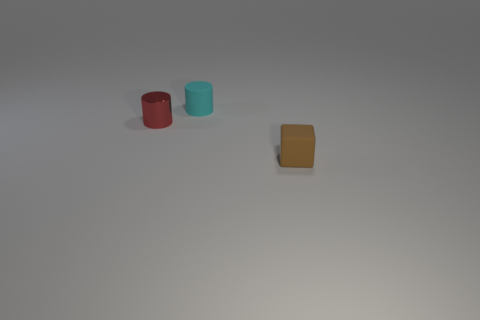Is there a large red matte ball?
Give a very brief answer. No. What shape is the tiny cyan object that is the same material as the tiny brown block?
Make the answer very short. Cylinder. Does the tiny red thing have the same shape as the tiny rubber object behind the small matte block?
Your answer should be very brief. Yes. There is a small thing that is left of the cylinder that is on the right side of the tiny red metal object; what is it made of?
Offer a terse response. Metal. What number of other objects are there of the same shape as the cyan matte object?
Keep it short and to the point. 1. There is a small matte object behind the small brown matte block; is its shape the same as the tiny matte thing in front of the tiny red metal thing?
Make the answer very short. No. Is there any other thing that has the same material as the cube?
Your answer should be compact. Yes. What is the tiny block made of?
Ensure brevity in your answer.  Rubber. There is a cylinder to the right of the metallic thing; what is its material?
Your response must be concise. Rubber. Are there any other things that have the same color as the metal cylinder?
Offer a very short reply. No. 